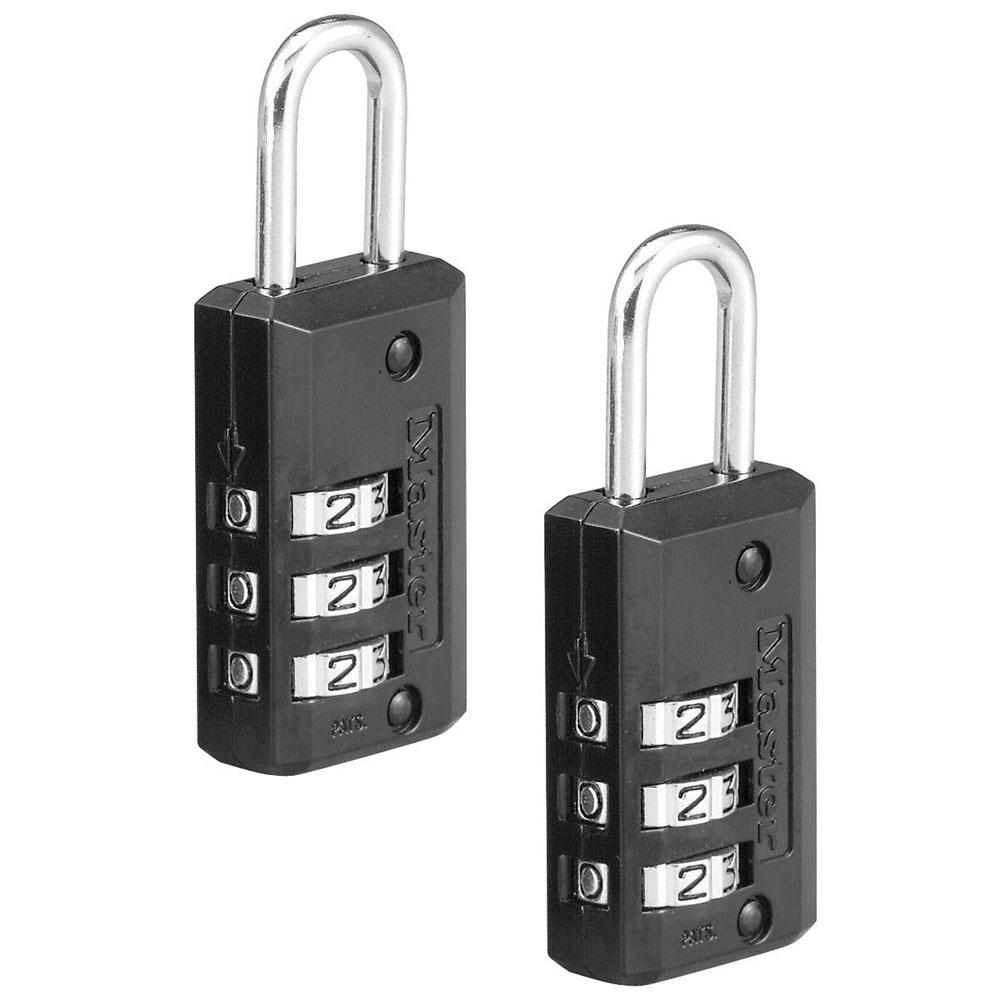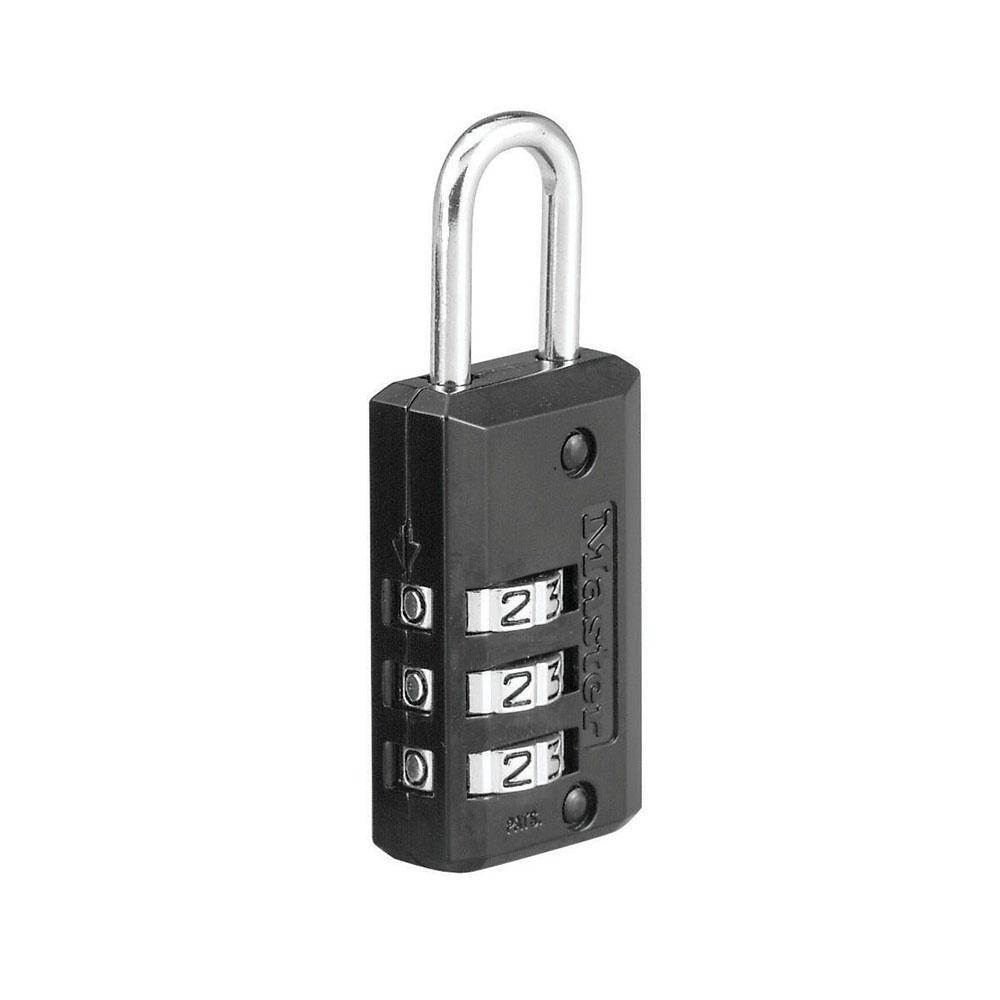The first image is the image on the left, the second image is the image on the right. Examine the images to the left and right. Is the description "Only one of the locks are mostly black in color." accurate? Answer yes or no. No. 